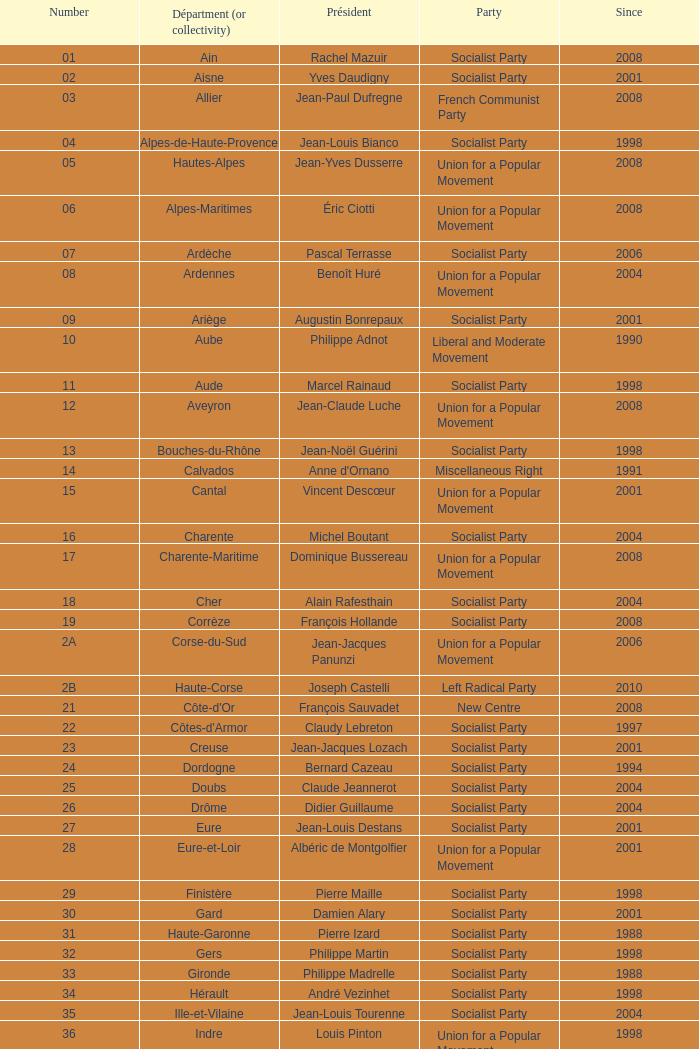Who is the president for the creuse department? Jean-Jacques Lozach. 